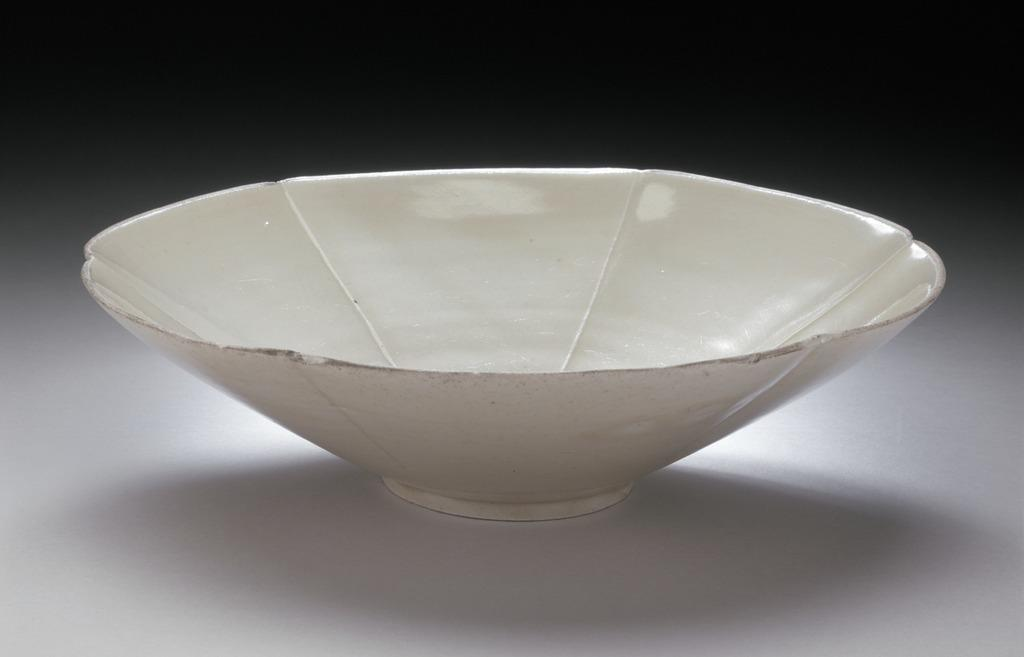What is present in the image? There is a bowl in the image. What can you tell me about the color of the bowl? The bowl is white in color. What type of ornament is hanging from the bowl in the image? There is no ornament hanging from the bowl in the image; it is simply a white bowl. What invention is being demonstrated in the image? There is no invention being demonstrated in the image; it is just a picture of a white bowl. 